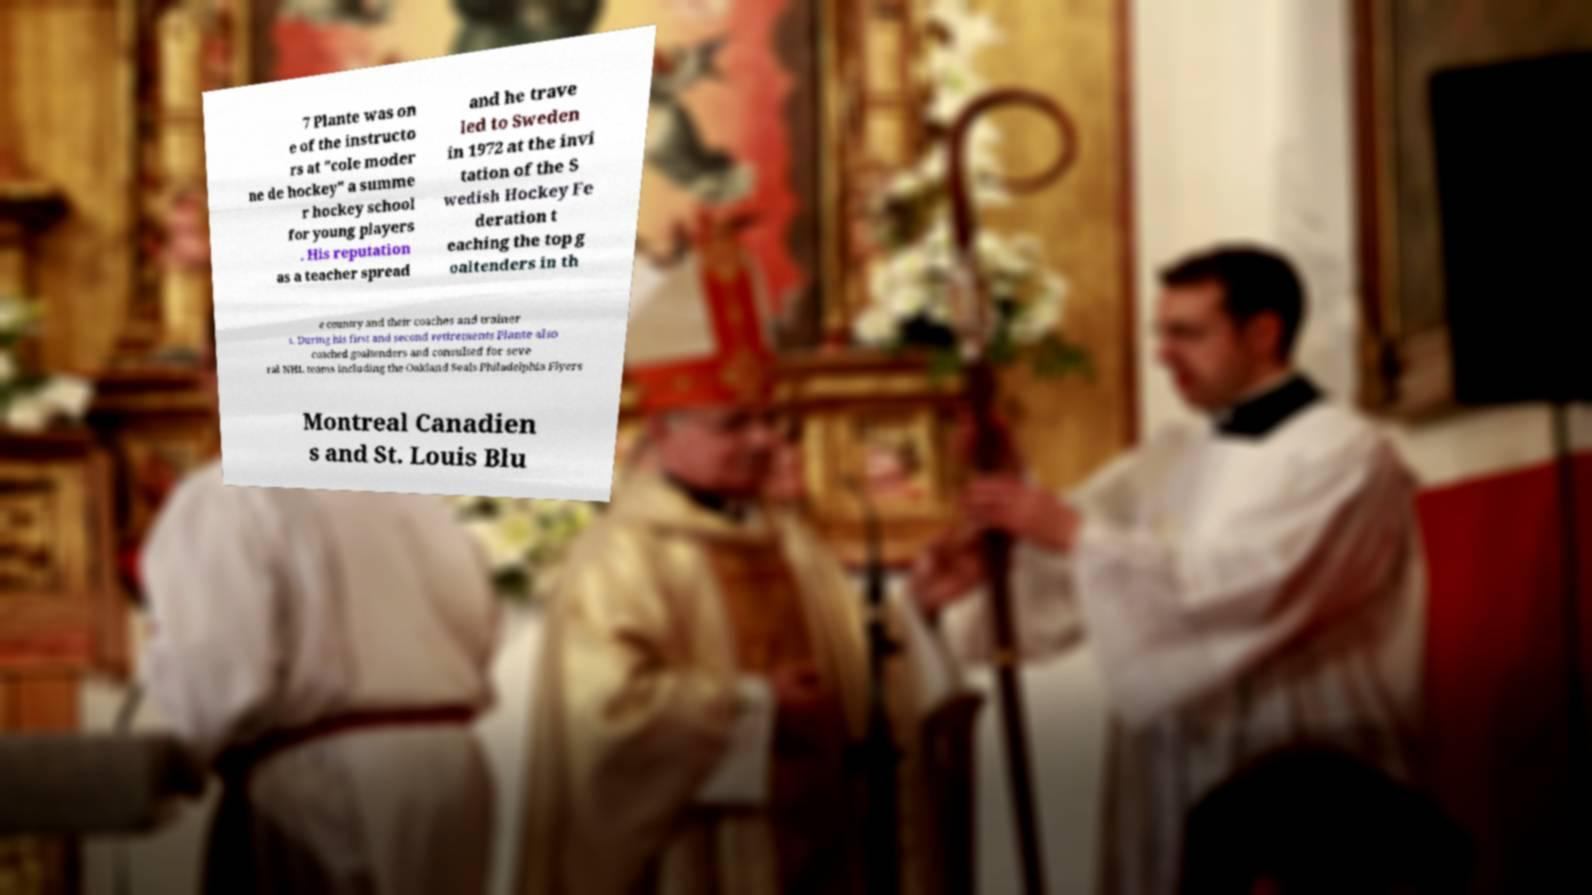Can you read and provide the text displayed in the image?This photo seems to have some interesting text. Can you extract and type it out for me? 7 Plante was on e of the instructo rs at "cole moder ne de hockey" a summe r hockey school for young players . His reputation as a teacher spread and he trave led to Sweden in 1972 at the invi tation of the S wedish Hockey Fe deration t eaching the top g oaltenders in th e country and their coaches and trainer s. During his first and second retirements Plante also coached goaltenders and consulted for seve ral NHL teams including the Oakland Seals Philadelphia Flyers Montreal Canadien s and St. Louis Blu 